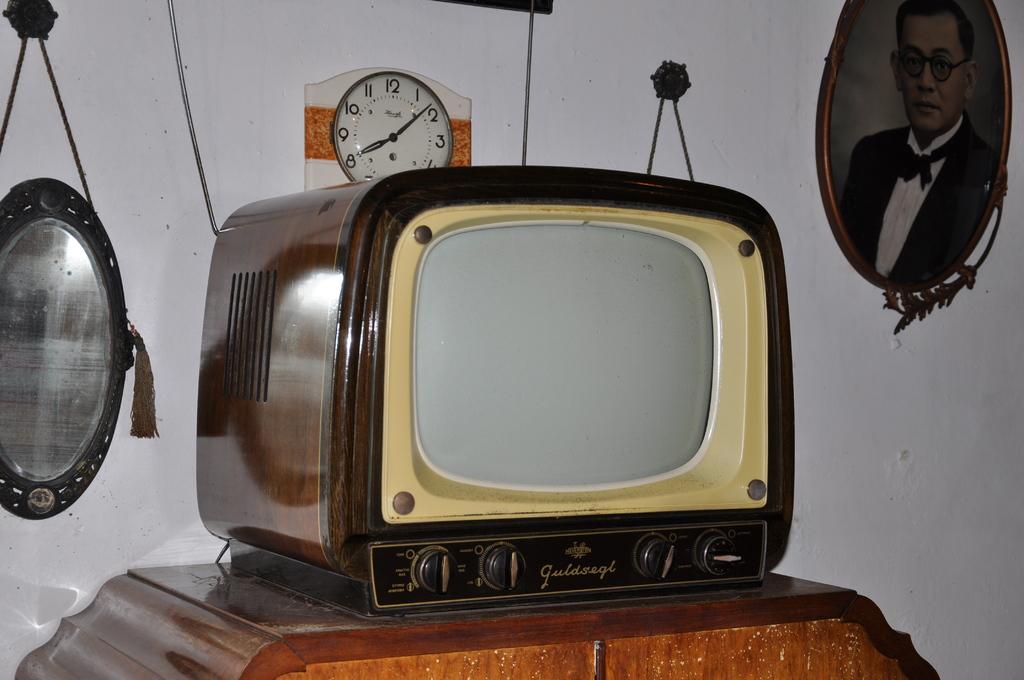What brand is this tv?
Make the answer very short. Guldsegl. 